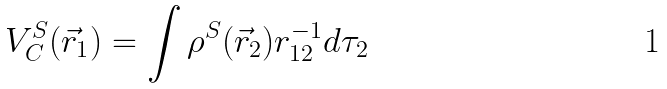Convert formula to latex. <formula><loc_0><loc_0><loc_500><loc_500>V _ { C } ^ { S } ( \vec { r } _ { 1 } ) = \int \rho ^ { S } ( \vec { r } _ { 2 } ) r _ { 1 2 } ^ { - 1 } d \tau _ { 2 }</formula> 